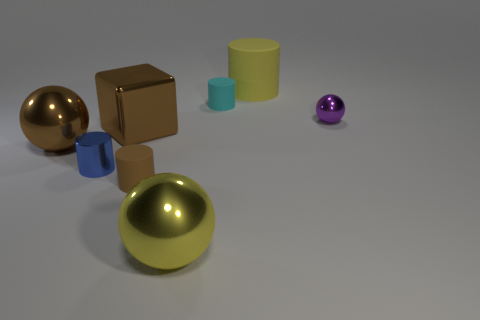Is there any other thing that is the same size as the brown ball?
Provide a succinct answer. Yes. What is the color of the cylinder that is the same material as the tiny purple sphere?
Make the answer very short. Blue. Are there fewer large yellow cylinders that are in front of the yellow cylinder than large balls behind the tiny brown matte object?
Give a very brief answer. Yes. What number of large cubes have the same color as the small ball?
Provide a succinct answer. 0. There is a large object that is the same color as the shiny block; what is it made of?
Give a very brief answer. Metal. What number of small shiny objects are behind the cube and to the left of the yellow ball?
Make the answer very short. 0. What is the small blue thing that is in front of the tiny purple object that is on the right side of the big brown sphere made of?
Your response must be concise. Metal. Is there a tiny yellow object made of the same material as the purple sphere?
Offer a very short reply. No. There is a yellow cylinder that is the same size as the yellow metallic thing; what is its material?
Your answer should be very brief. Rubber. How big is the metal object that is right of the yellow thing that is behind the tiny brown thing in front of the cyan rubber cylinder?
Offer a very short reply. Small. 